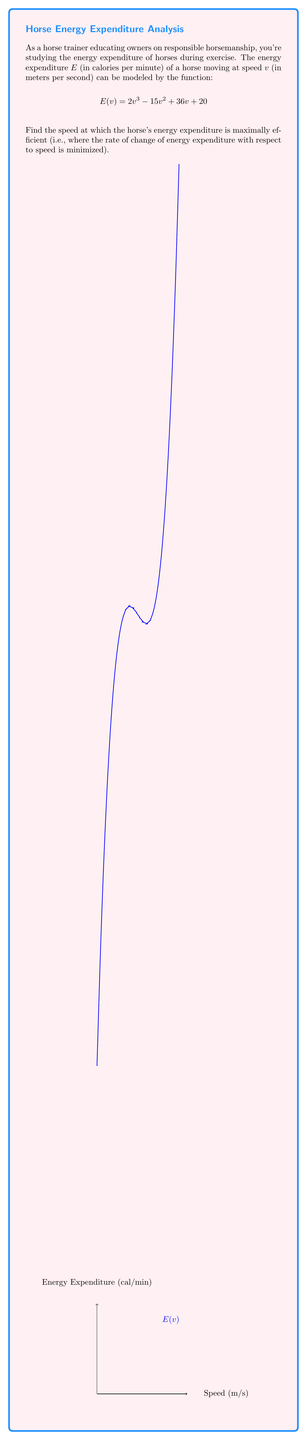Could you help me with this problem? To find the speed at which the horse's energy expenditure is maximally efficient, we need to find the point where the rate of change of energy expenditure with respect to speed is minimized. This is equivalent to finding the point where the second derivative of $E(v)$ equals zero.

Step 1: Find the first derivative of $E(v)$.
$$E'(v) = 6v^2 - 30v + 36$$

Step 2: Find the second derivative of $E(v)$.
$$E''(v) = 12v - 30$$

Step 3: Set the second derivative equal to zero and solve for $v$.
$$\begin{align}
12v - 30 &= 0 \\
12v &= 30 \\
v &= \frac{30}{12} = \frac{5}{2} = 2.5
\end{align}$$

Step 4: Verify that this is a minimum point for $E'(v)$ (and thus a point of maximum efficiency) by checking the sign of $E'''(v)$.
$$E'''(v) = 12$$
Since $E'''(v)$ is positive, the critical point we found is indeed a minimum for $E'(v)$.

Therefore, the horse's energy expenditure is maximally efficient at a speed of 2.5 meters per second.
Answer: 2.5 m/s 